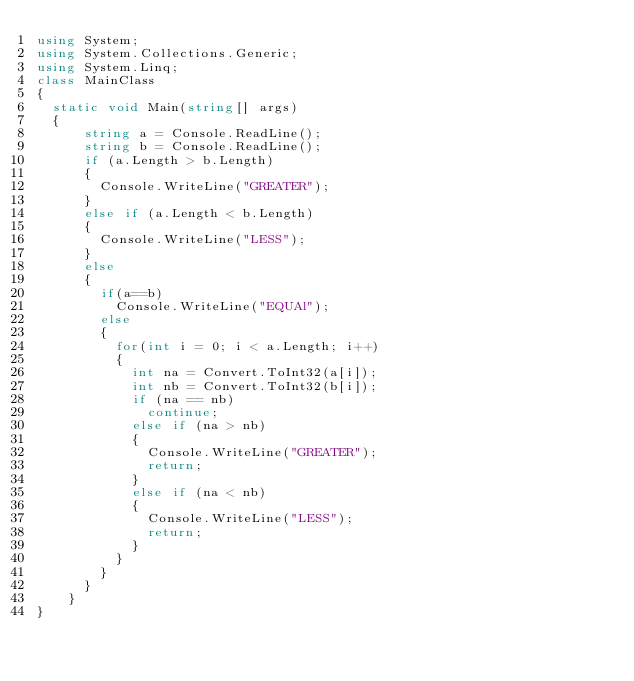Convert code to text. <code><loc_0><loc_0><loc_500><loc_500><_C#_>using System;
using System.Collections.Generic;
using System.Linq;
class MainClass
{
	static void Main(string[] args)
	{
      string a = Console.ReadLine();
      string b = Console.ReadLine();
      if (a.Length > b.Length)
      {
        Console.WriteLine("GREATER");
      }
      else if (a.Length < b.Length)
      {
        Console.WriteLine("LESS");
      }
      else
      {
        if(a==b)
          Console.WriteLine("EQUAl");
        else
        {
          for(int i = 0; i < a.Length; i++)
          {
            int na = Convert.ToInt32(a[i]);
            int nb = Convert.ToInt32(b[i]);
            if (na == nb)
              continue;
            else if (na > nb)
            {
              Console.WriteLine("GREATER");
              return;
            }
            else if (na < nb)
            {
              Console.WriteLine("LESS");
              return;
            }
          }
        }
      }
    }
}</code> 